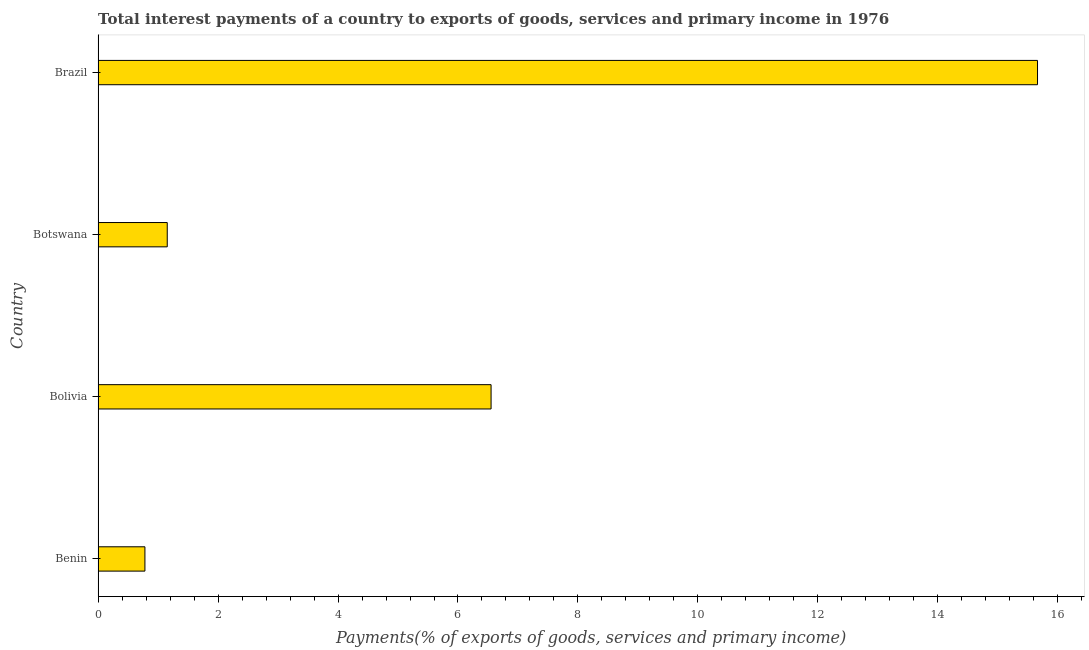Does the graph contain any zero values?
Keep it short and to the point. No. Does the graph contain grids?
Provide a succinct answer. No. What is the title of the graph?
Give a very brief answer. Total interest payments of a country to exports of goods, services and primary income in 1976. What is the label or title of the X-axis?
Offer a very short reply. Payments(% of exports of goods, services and primary income). What is the label or title of the Y-axis?
Make the answer very short. Country. What is the total interest payments on external debt in Benin?
Offer a very short reply. 0.78. Across all countries, what is the maximum total interest payments on external debt?
Keep it short and to the point. 15.66. Across all countries, what is the minimum total interest payments on external debt?
Ensure brevity in your answer.  0.78. In which country was the total interest payments on external debt maximum?
Offer a very short reply. Brazil. In which country was the total interest payments on external debt minimum?
Provide a succinct answer. Benin. What is the sum of the total interest payments on external debt?
Offer a very short reply. 24.15. What is the difference between the total interest payments on external debt in Bolivia and Brazil?
Make the answer very short. -9.11. What is the average total interest payments on external debt per country?
Offer a very short reply. 6.04. What is the median total interest payments on external debt?
Make the answer very short. 3.85. What is the ratio of the total interest payments on external debt in Benin to that in Botswana?
Provide a short and direct response. 0.68. What is the difference between the highest and the second highest total interest payments on external debt?
Keep it short and to the point. 9.11. Is the sum of the total interest payments on external debt in Benin and Bolivia greater than the maximum total interest payments on external debt across all countries?
Keep it short and to the point. No. What is the difference between the highest and the lowest total interest payments on external debt?
Give a very brief answer. 14.88. What is the difference between two consecutive major ticks on the X-axis?
Make the answer very short. 2. Are the values on the major ticks of X-axis written in scientific E-notation?
Make the answer very short. No. What is the Payments(% of exports of goods, services and primary income) of Benin?
Make the answer very short. 0.78. What is the Payments(% of exports of goods, services and primary income) of Bolivia?
Your response must be concise. 6.55. What is the Payments(% of exports of goods, services and primary income) in Botswana?
Provide a succinct answer. 1.15. What is the Payments(% of exports of goods, services and primary income) in Brazil?
Keep it short and to the point. 15.66. What is the difference between the Payments(% of exports of goods, services and primary income) in Benin and Bolivia?
Ensure brevity in your answer.  -5.77. What is the difference between the Payments(% of exports of goods, services and primary income) in Benin and Botswana?
Offer a terse response. -0.37. What is the difference between the Payments(% of exports of goods, services and primary income) in Benin and Brazil?
Ensure brevity in your answer.  -14.88. What is the difference between the Payments(% of exports of goods, services and primary income) in Bolivia and Botswana?
Ensure brevity in your answer.  5.4. What is the difference between the Payments(% of exports of goods, services and primary income) in Bolivia and Brazil?
Provide a succinct answer. -9.11. What is the difference between the Payments(% of exports of goods, services and primary income) in Botswana and Brazil?
Provide a succinct answer. -14.51. What is the ratio of the Payments(% of exports of goods, services and primary income) in Benin to that in Bolivia?
Offer a very short reply. 0.12. What is the ratio of the Payments(% of exports of goods, services and primary income) in Benin to that in Botswana?
Make the answer very short. 0.68. What is the ratio of the Payments(% of exports of goods, services and primary income) in Bolivia to that in Botswana?
Your response must be concise. 5.68. What is the ratio of the Payments(% of exports of goods, services and primary income) in Bolivia to that in Brazil?
Keep it short and to the point. 0.42. What is the ratio of the Payments(% of exports of goods, services and primary income) in Botswana to that in Brazil?
Your answer should be compact. 0.07. 